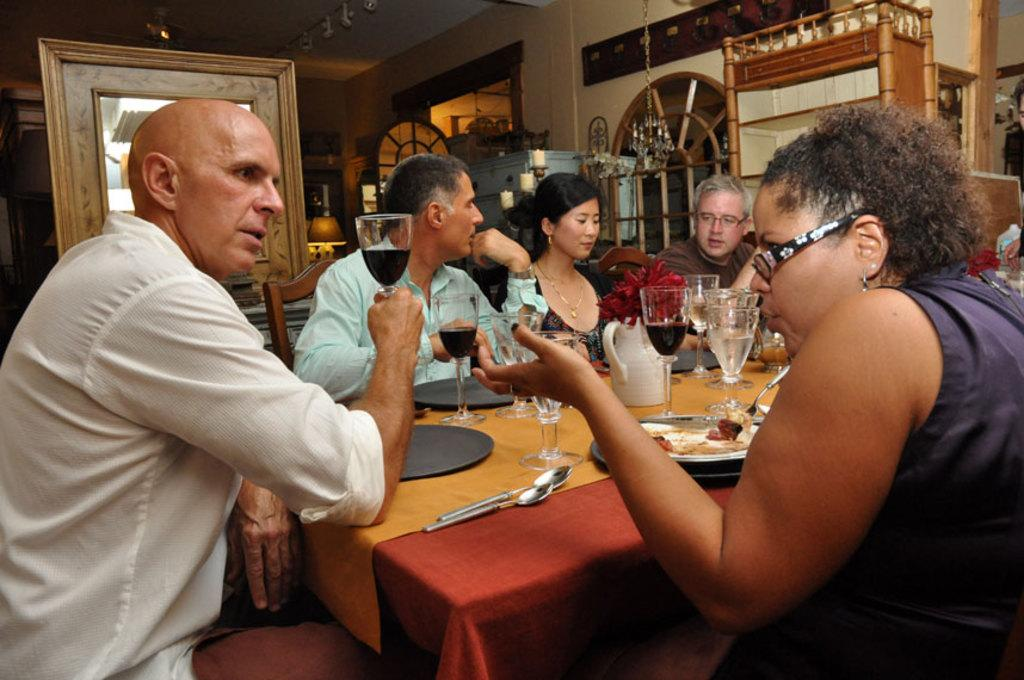How many people are in the image? There is a group of people in the image. What are the people doing in the image? The people are sitting in chairs. What is in front of the people? There is a table in front of the people. What can be found on the table? The table has eatables and drinks on it. What type of stocking is the queen wearing in the image? There is no queen or stocking present in the image. What type of wood is the table made of in the image? The type of wood the table is made of cannot be determined from the image. 